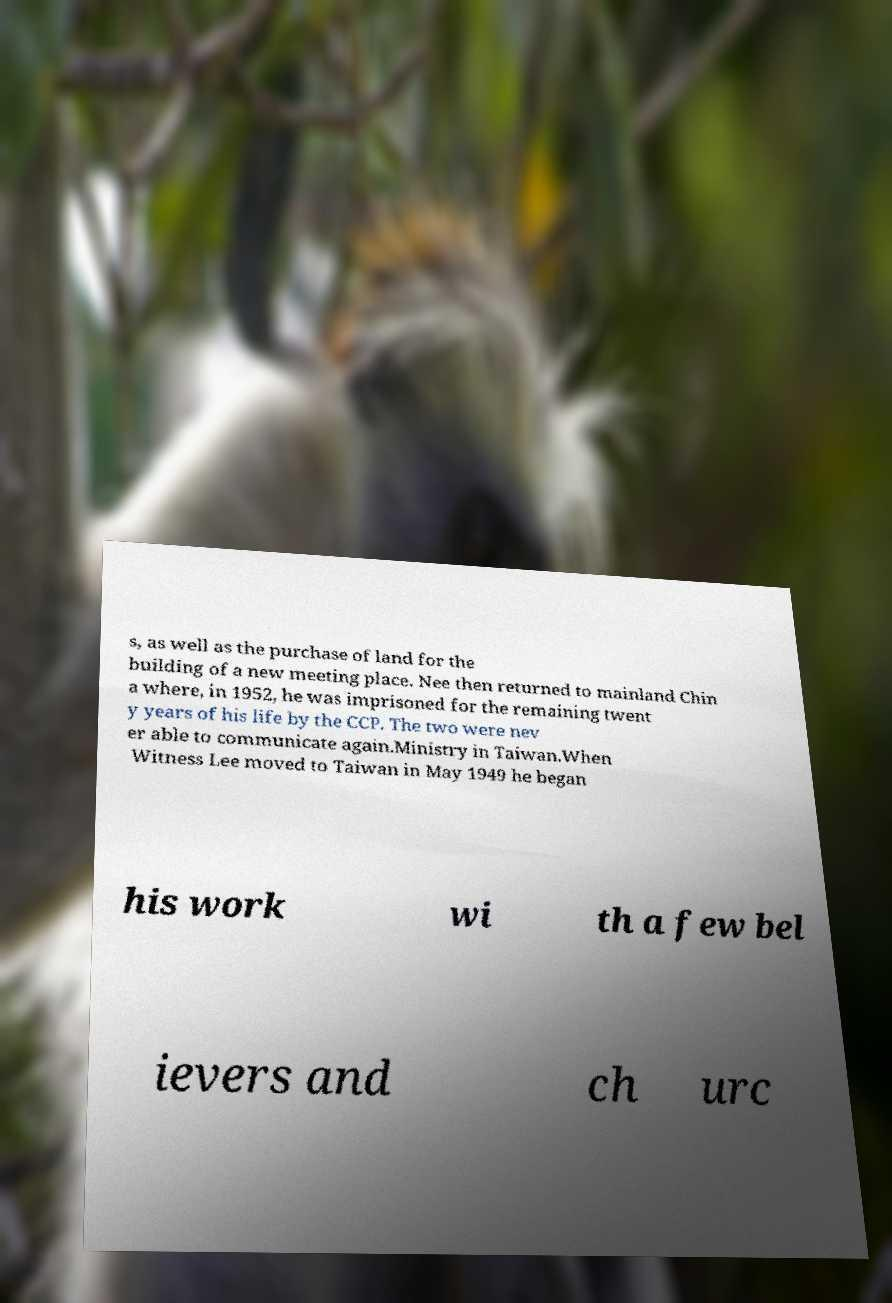I need the written content from this picture converted into text. Can you do that? s, as well as the purchase of land for the building of a new meeting place. Nee then returned to mainland Chin a where, in 1952, he was imprisoned for the remaining twent y years of his life by the CCP. The two were nev er able to communicate again.Ministry in Taiwan.When Witness Lee moved to Taiwan in May 1949 he began his work wi th a few bel ievers and ch urc 